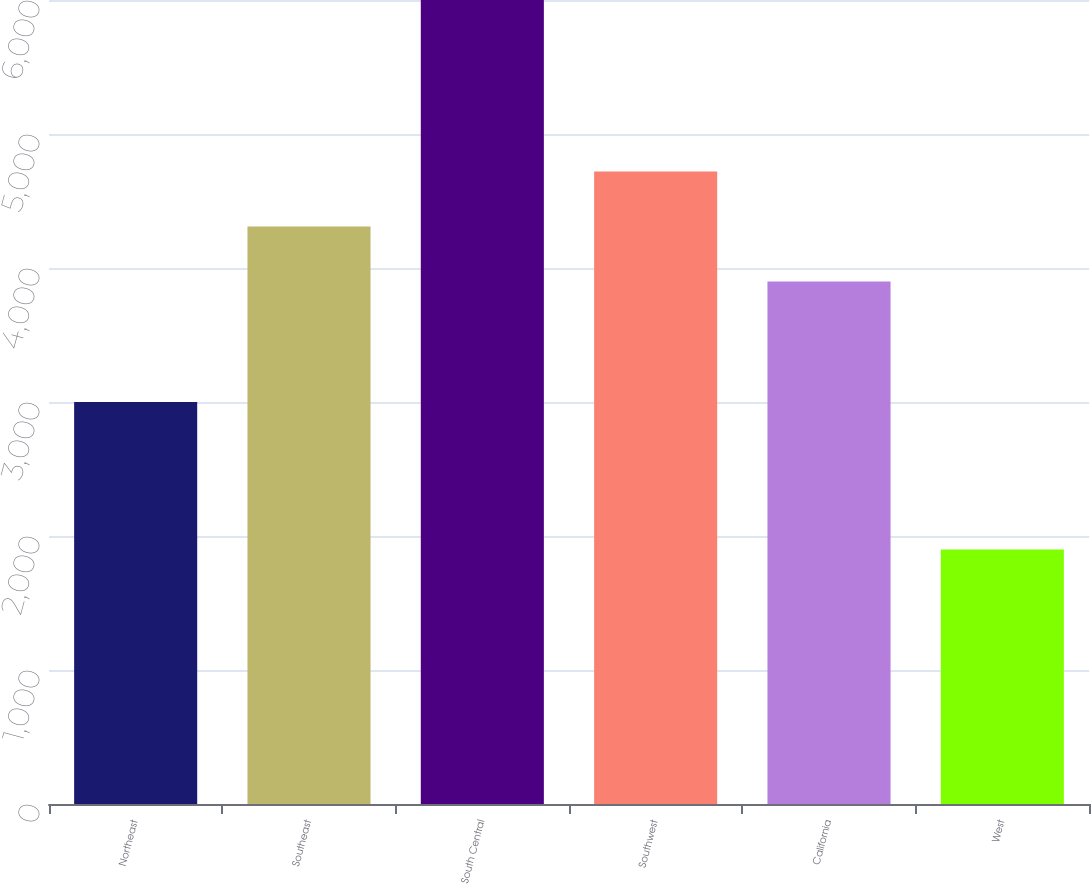<chart> <loc_0><loc_0><loc_500><loc_500><bar_chart><fcel>Northeast<fcel>Southeast<fcel>South Central<fcel>Southwest<fcel>California<fcel>West<nl><fcel>3000<fcel>4310<fcel>6000<fcel>4720<fcel>3900<fcel>1900<nl></chart> 